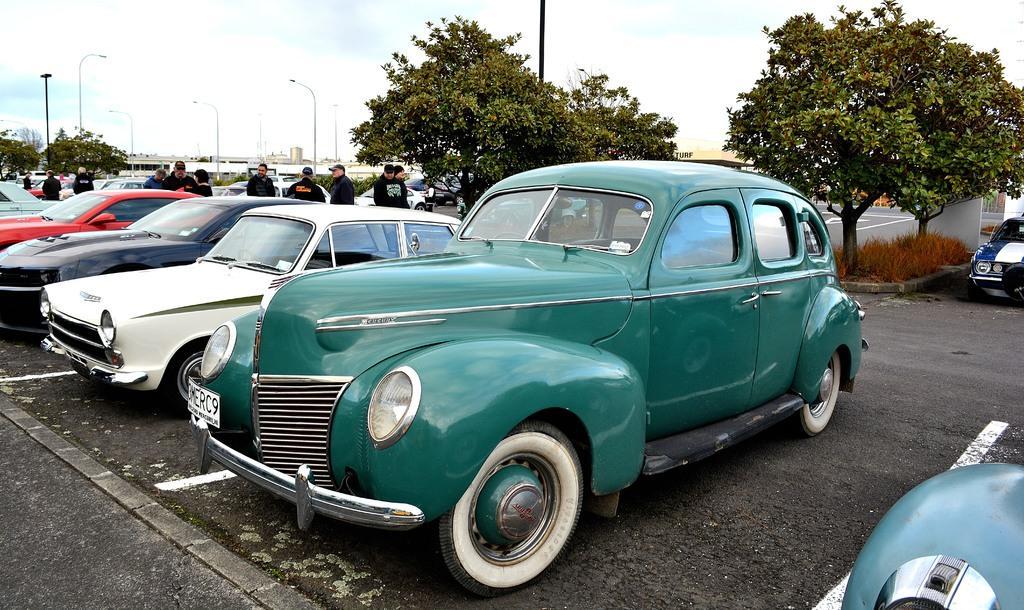Could you give a brief overview of what you see in this image? In the picture I can see vehicles and people standing on the road. In the background I can see pole lights, trees, the sky, buildings and some other objects. 